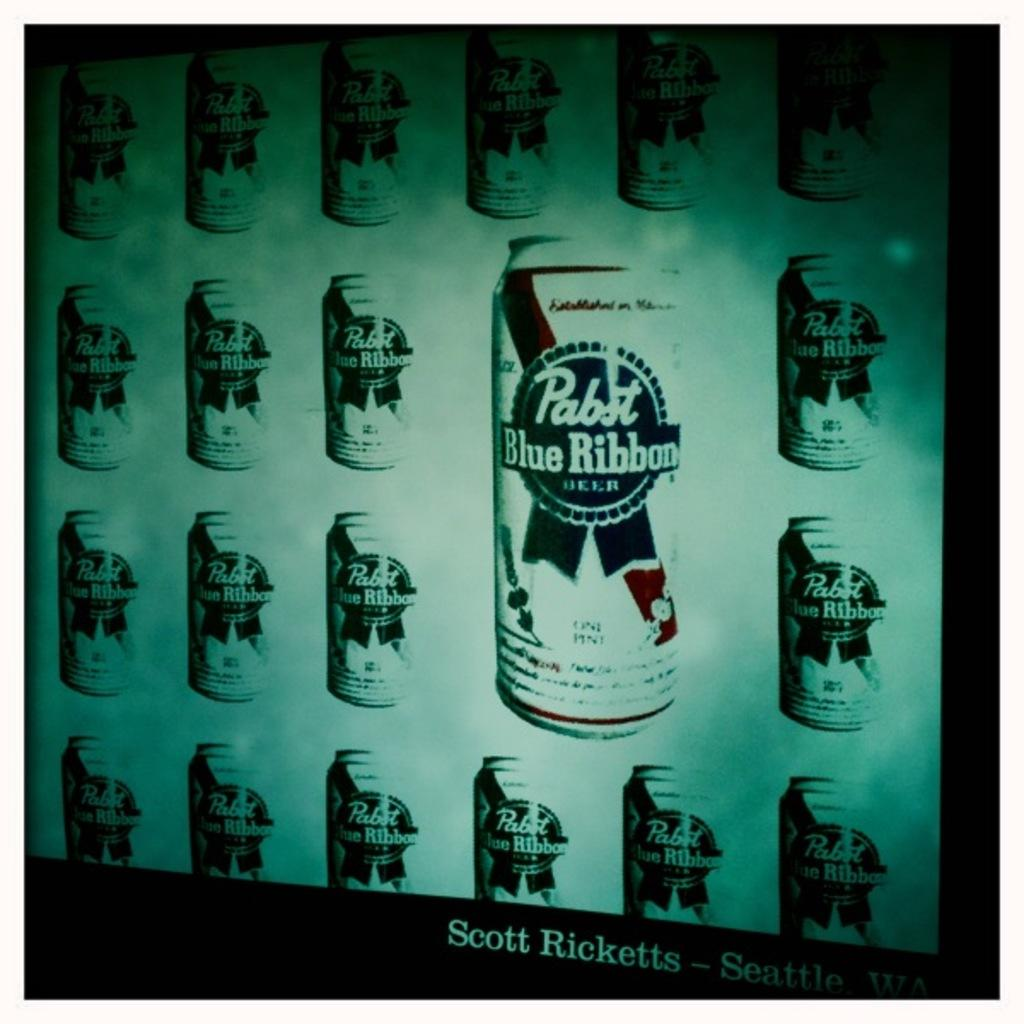<image>
Create a compact narrative representing the image presented. Several cans of Pabst Blue Ribbon appear on a greenish background. 